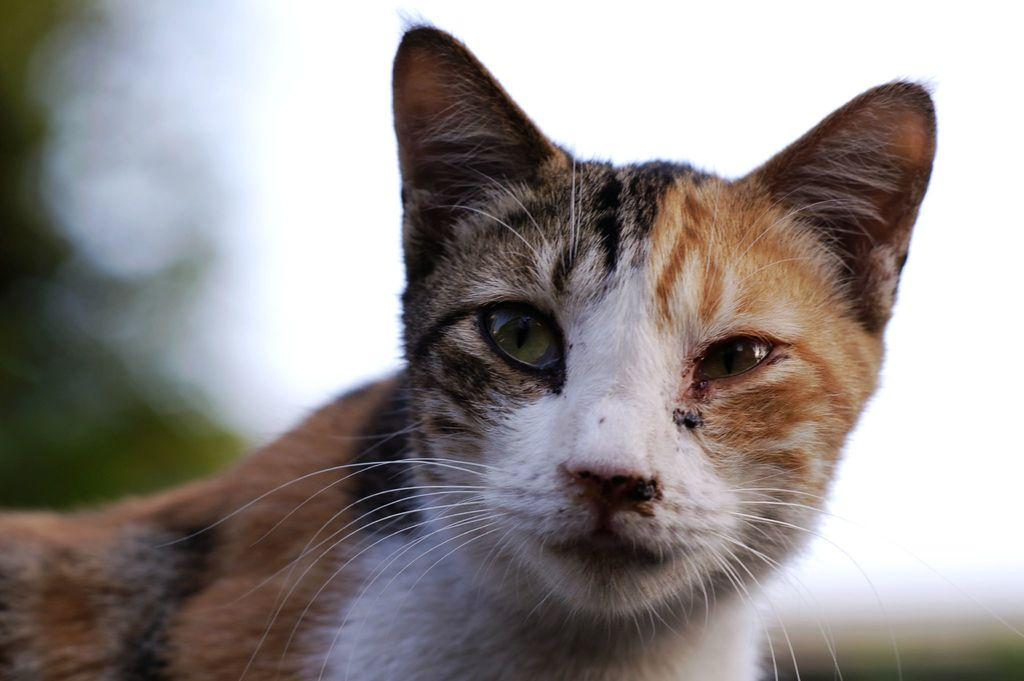What type of animal is in the image? There is a cat in the image. Can you describe the background of the image? The background of the image is blurred. What type of car is featured in the background of the image? There is no car present in the image; the background is blurred. What kind of flag can be seen in the image? There is no flag present in the image; it only features a cat and a blurred background. 